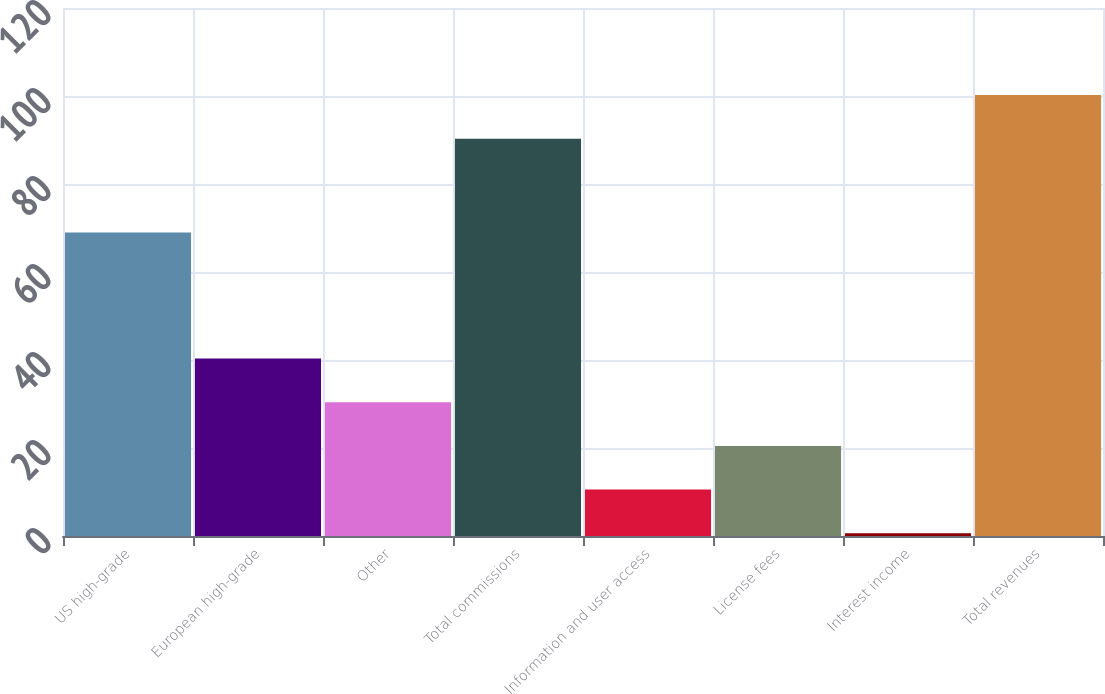<chart> <loc_0><loc_0><loc_500><loc_500><bar_chart><fcel>US high-grade<fcel>European high-grade<fcel>Other<fcel>Total commissions<fcel>Information and user access<fcel>License fees<fcel>Interest income<fcel>Total revenues<nl><fcel>69<fcel>40.36<fcel>30.42<fcel>90.3<fcel>10.54<fcel>20.48<fcel>0.6<fcel>100.24<nl></chart> 